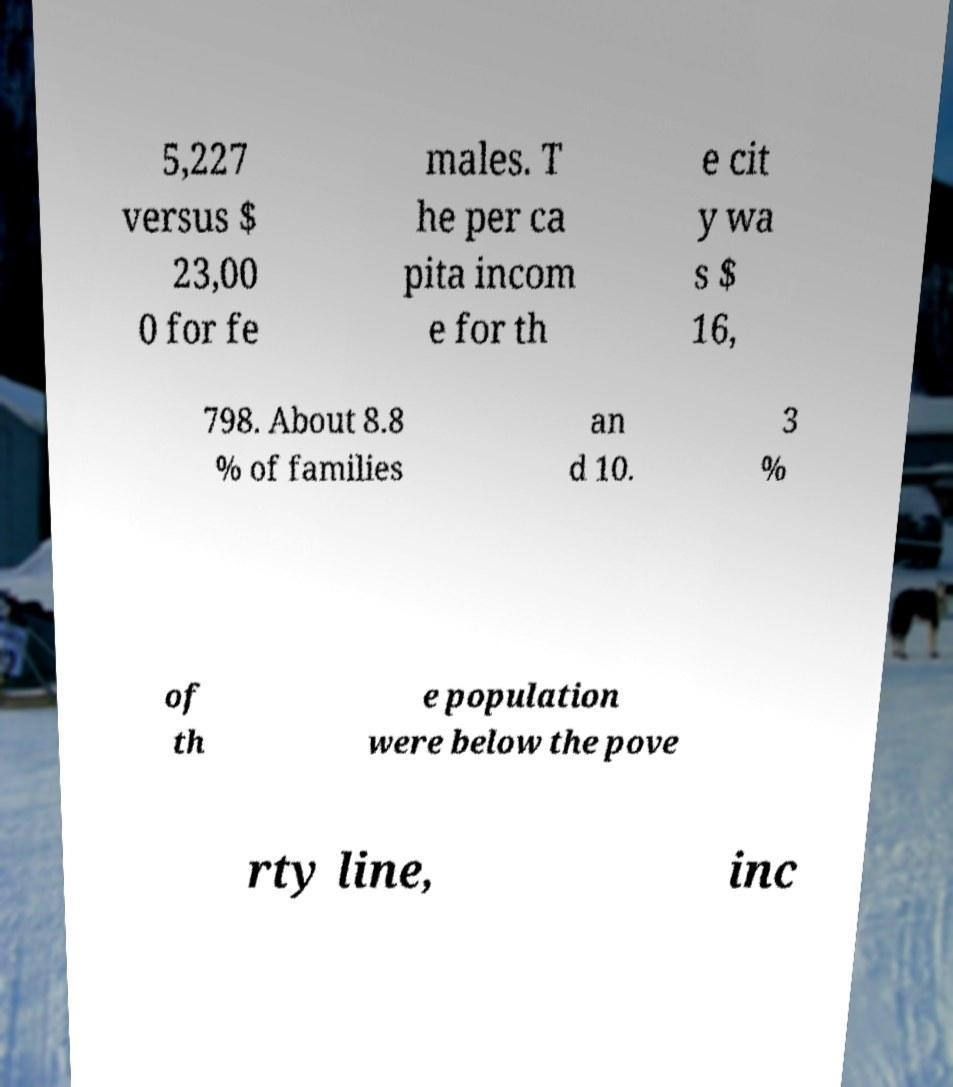Can you read and provide the text displayed in the image?This photo seems to have some interesting text. Can you extract and type it out for me? 5,227 versus $ 23,00 0 for fe males. T he per ca pita incom e for th e cit y wa s $ 16, 798. About 8.8 % of families an d 10. 3 % of th e population were below the pove rty line, inc 